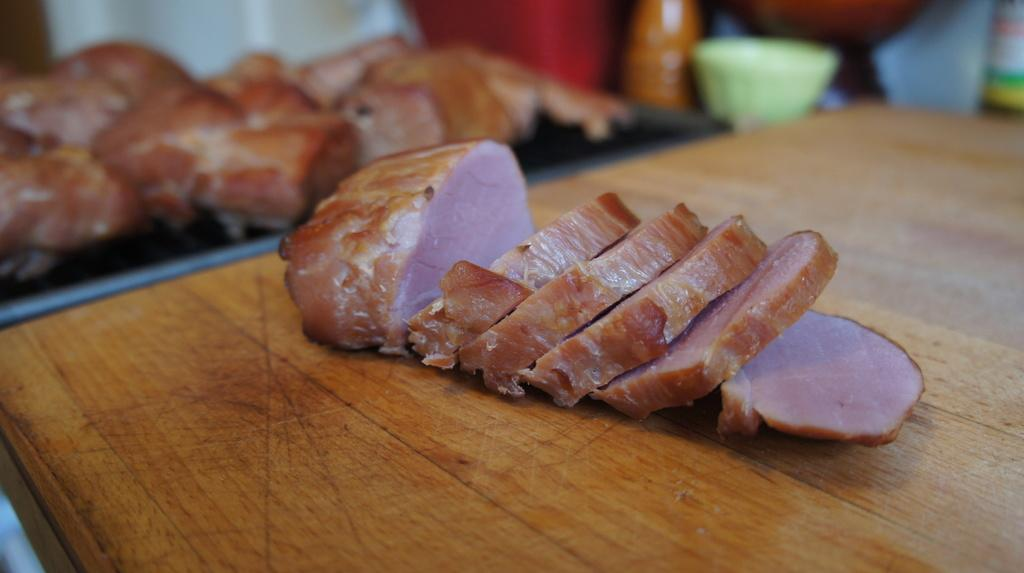What type of material is the plank in the image made of? The wooden plank in the image is made of wood. What can be found on the wooden plank? There is food and a bowl on the wooden plank. What else is present on the wooden plank besides food and a bowl? There are other objects on the wooden plank. How are all these elements arranged in the image? All these elements are placed on a platform. What type of ray is swimming under the wooden plank in the image? There is no ray present in the image; it is a wooden plank with food, a bowl, and other objects on a platform. What type of scarf is the farmer wearing in the image? There is no farmer or scarf present in the image. 